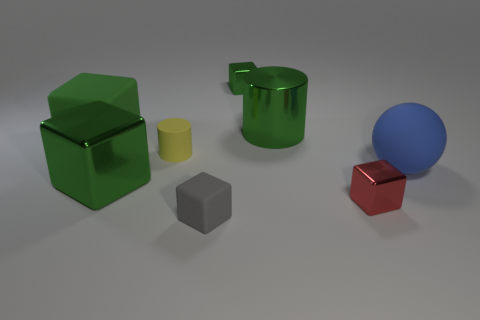Subtract all brown cylinders. How many green cubes are left? 3 Subtract all yellow blocks. Subtract all yellow balls. How many blocks are left? 5 Add 1 gray matte cubes. How many objects exist? 9 Subtract all cylinders. How many objects are left? 6 Subtract all small red shiny objects. Subtract all gray matte blocks. How many objects are left? 6 Add 8 tiny rubber cubes. How many tiny rubber cubes are left? 9 Add 5 tiny cyan cylinders. How many tiny cyan cylinders exist? 5 Subtract 0 purple blocks. How many objects are left? 8 